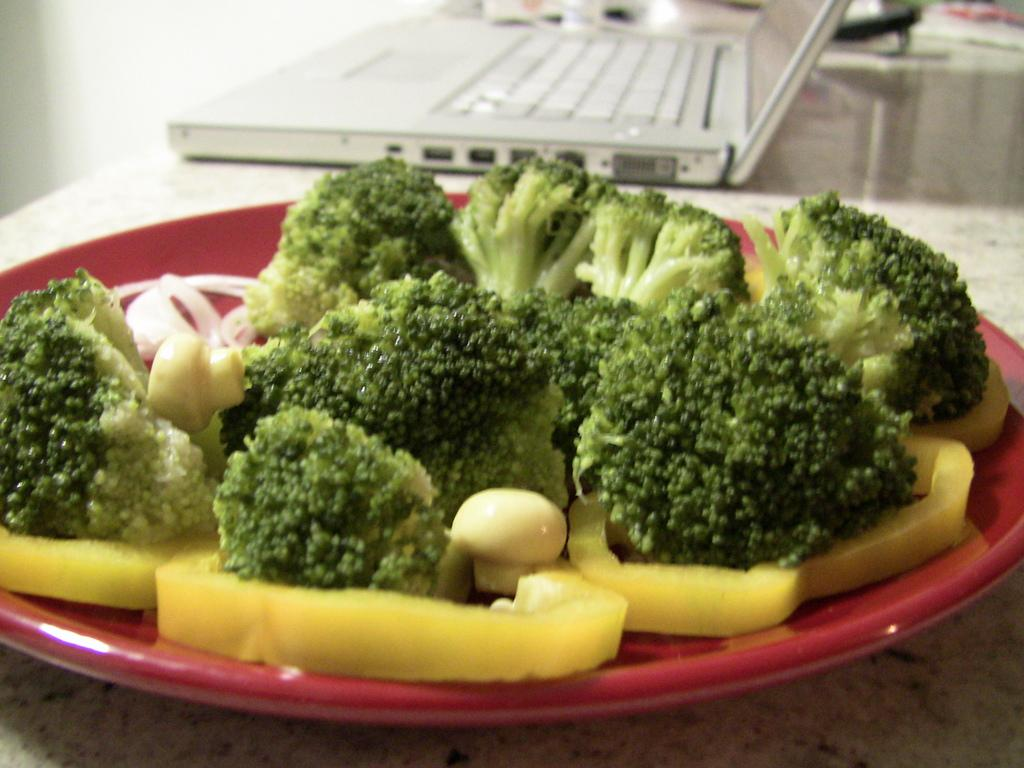What is on the plate that is visible in the image? There is a plate with broccoli pieces in the image. What electronic device can be seen in the image? There is a laptop in the image. What else is present in the image besides the plate and laptop? There are other objects present in the image. Where are these elements located in the image? These elements are placed on a platform. How does the broccoli help the laptop in the image? The broccoli does not help the laptop in the image; they are separate elements with different functions. 